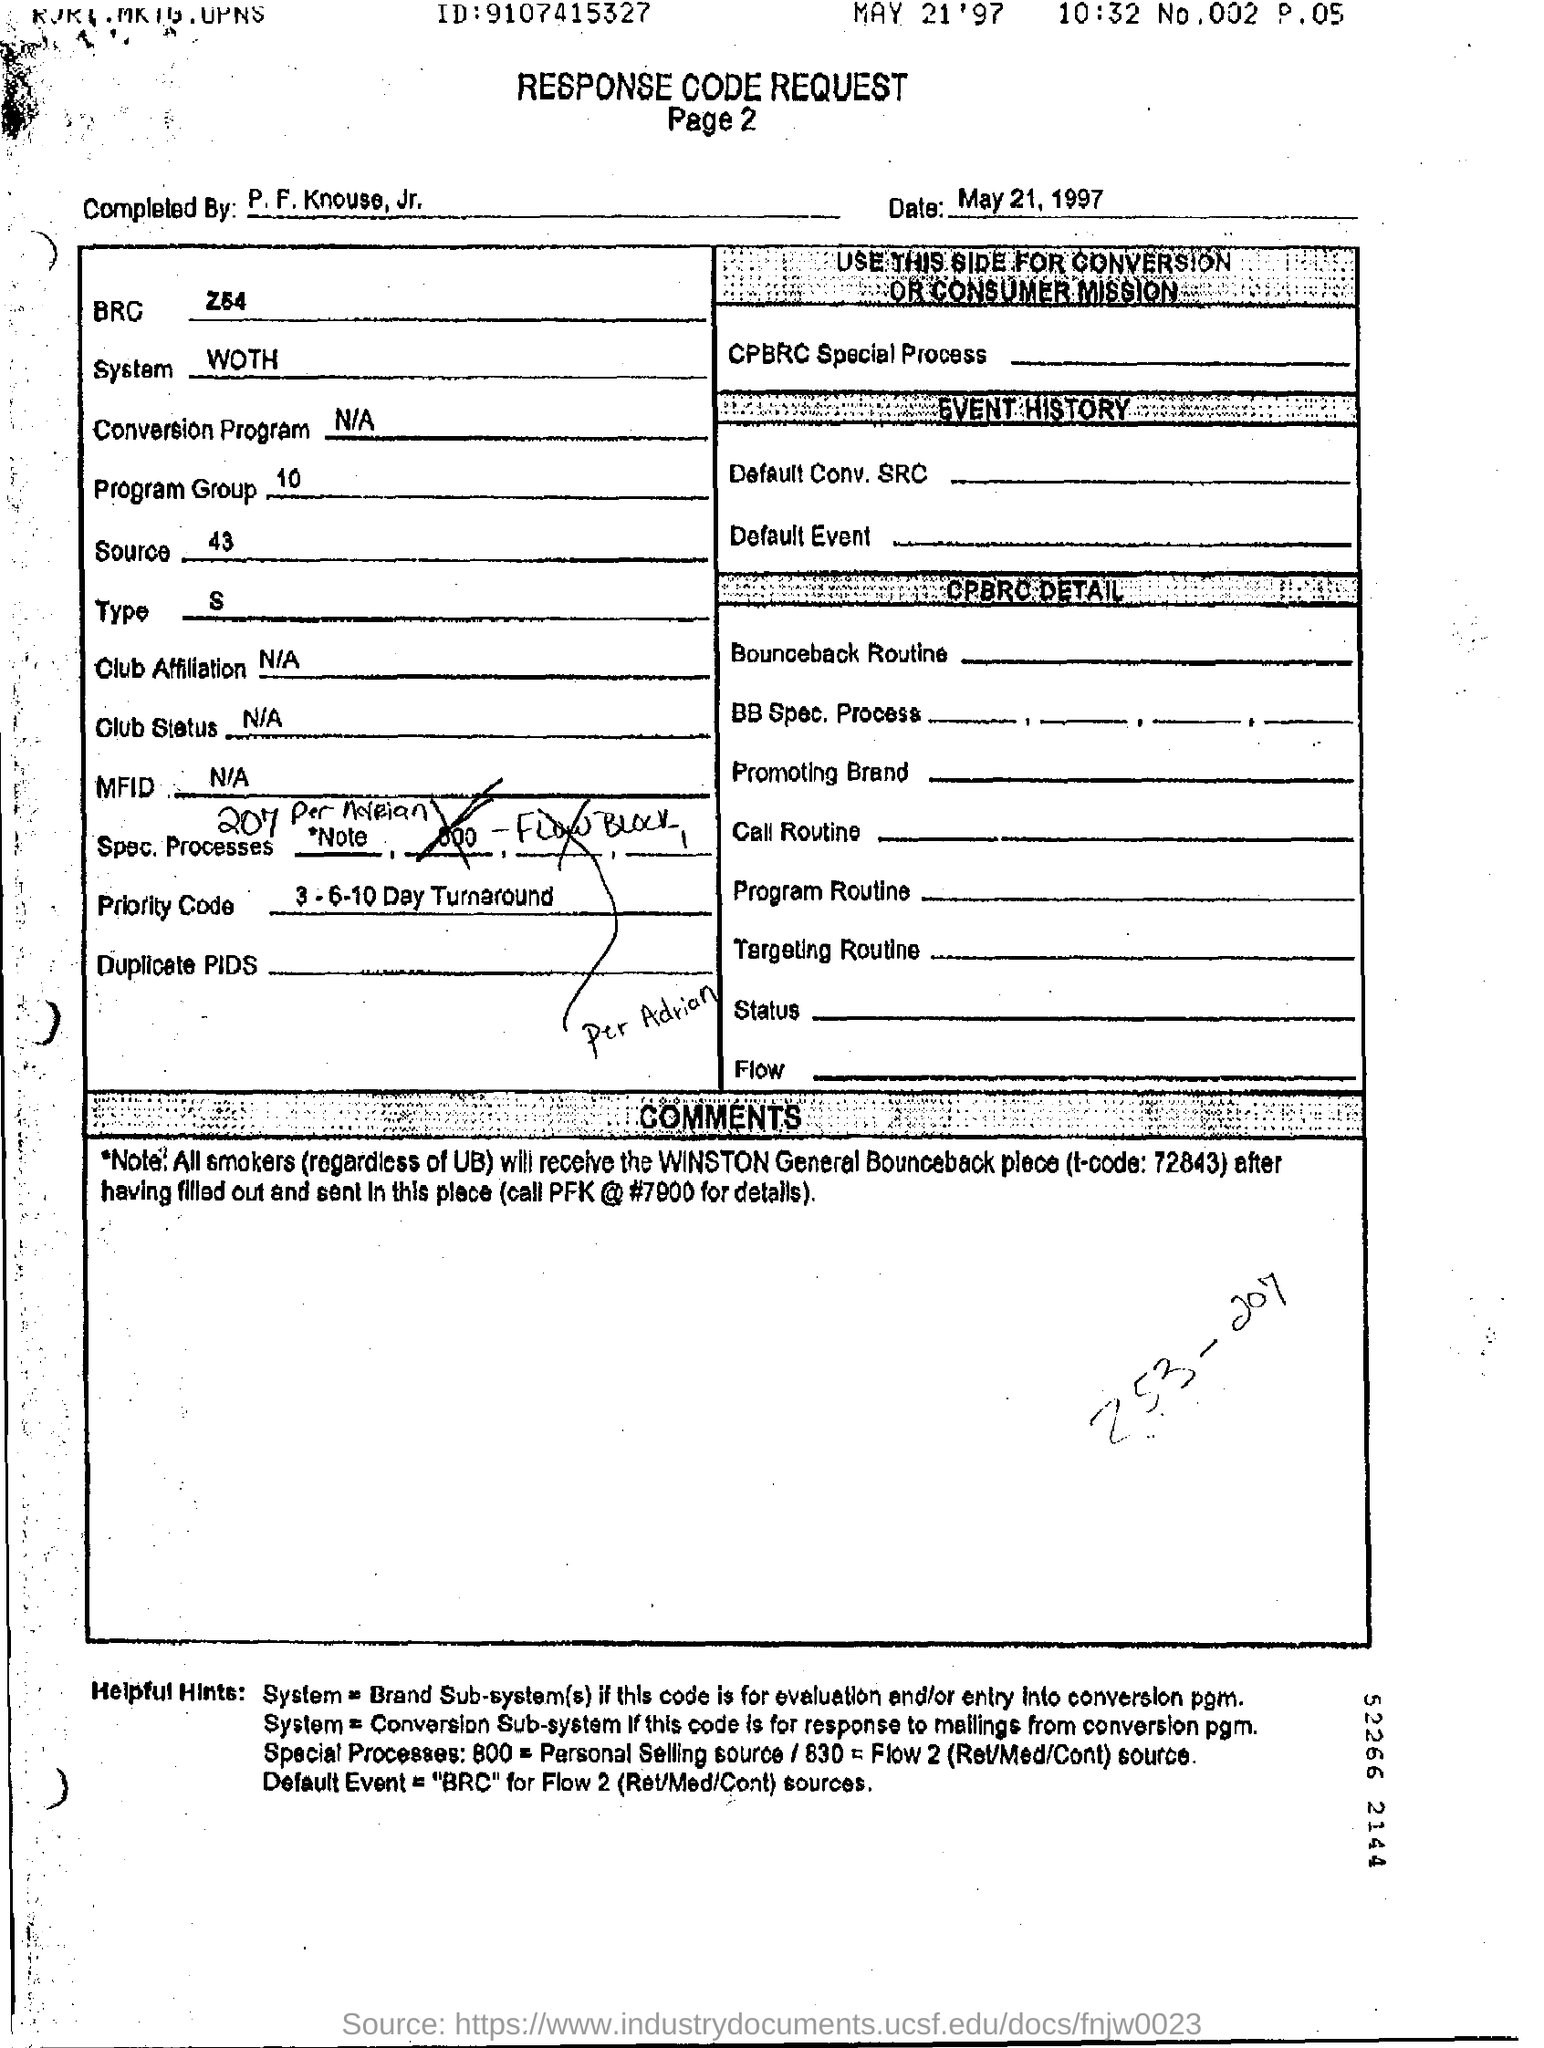What is the program group?
Offer a very short reply. 10. What is the system mentioned in the form?
Make the answer very short. WOTH. 